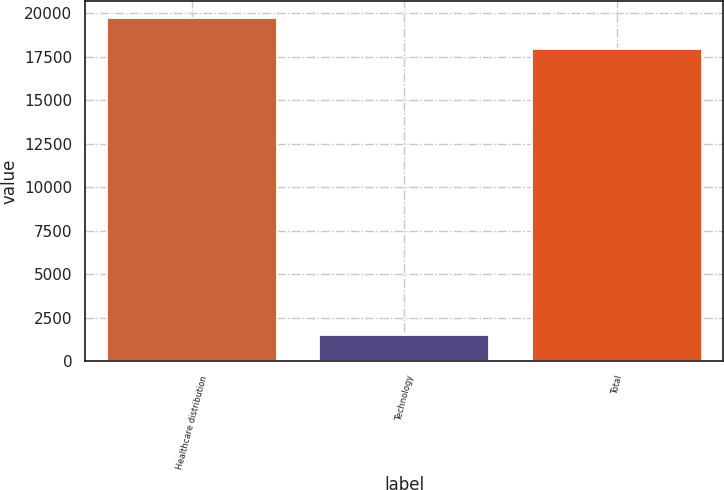<chart> <loc_0><loc_0><loc_500><loc_500><bar_chart><fcel>Healthcare distribution<fcel>Technology<fcel>Total<nl><fcel>19740.6<fcel>1527<fcel>17946<nl></chart> 